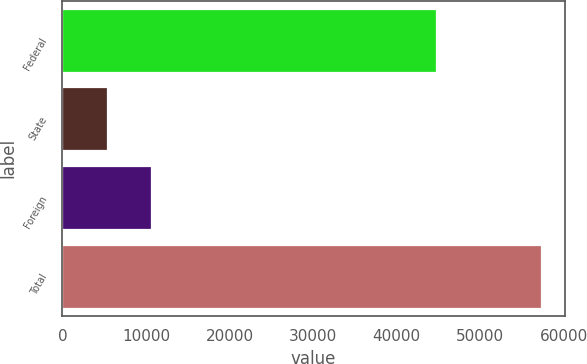Convert chart. <chart><loc_0><loc_0><loc_500><loc_500><bar_chart><fcel>Federal<fcel>State<fcel>Foreign<fcel>Total<nl><fcel>44737<fcel>5391<fcel>10578.1<fcel>57262<nl></chart> 